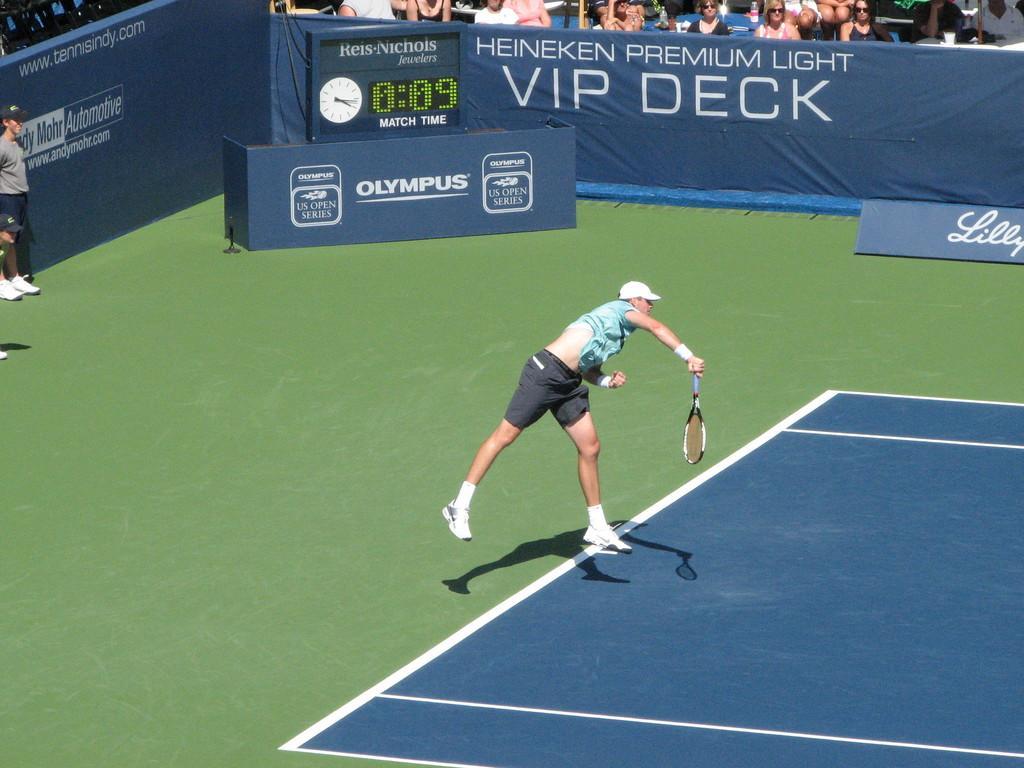How would you summarize this image in a sentence or two? A man is jumping and holding tennis racket in his hand,behind him there are few people,hoarding. 